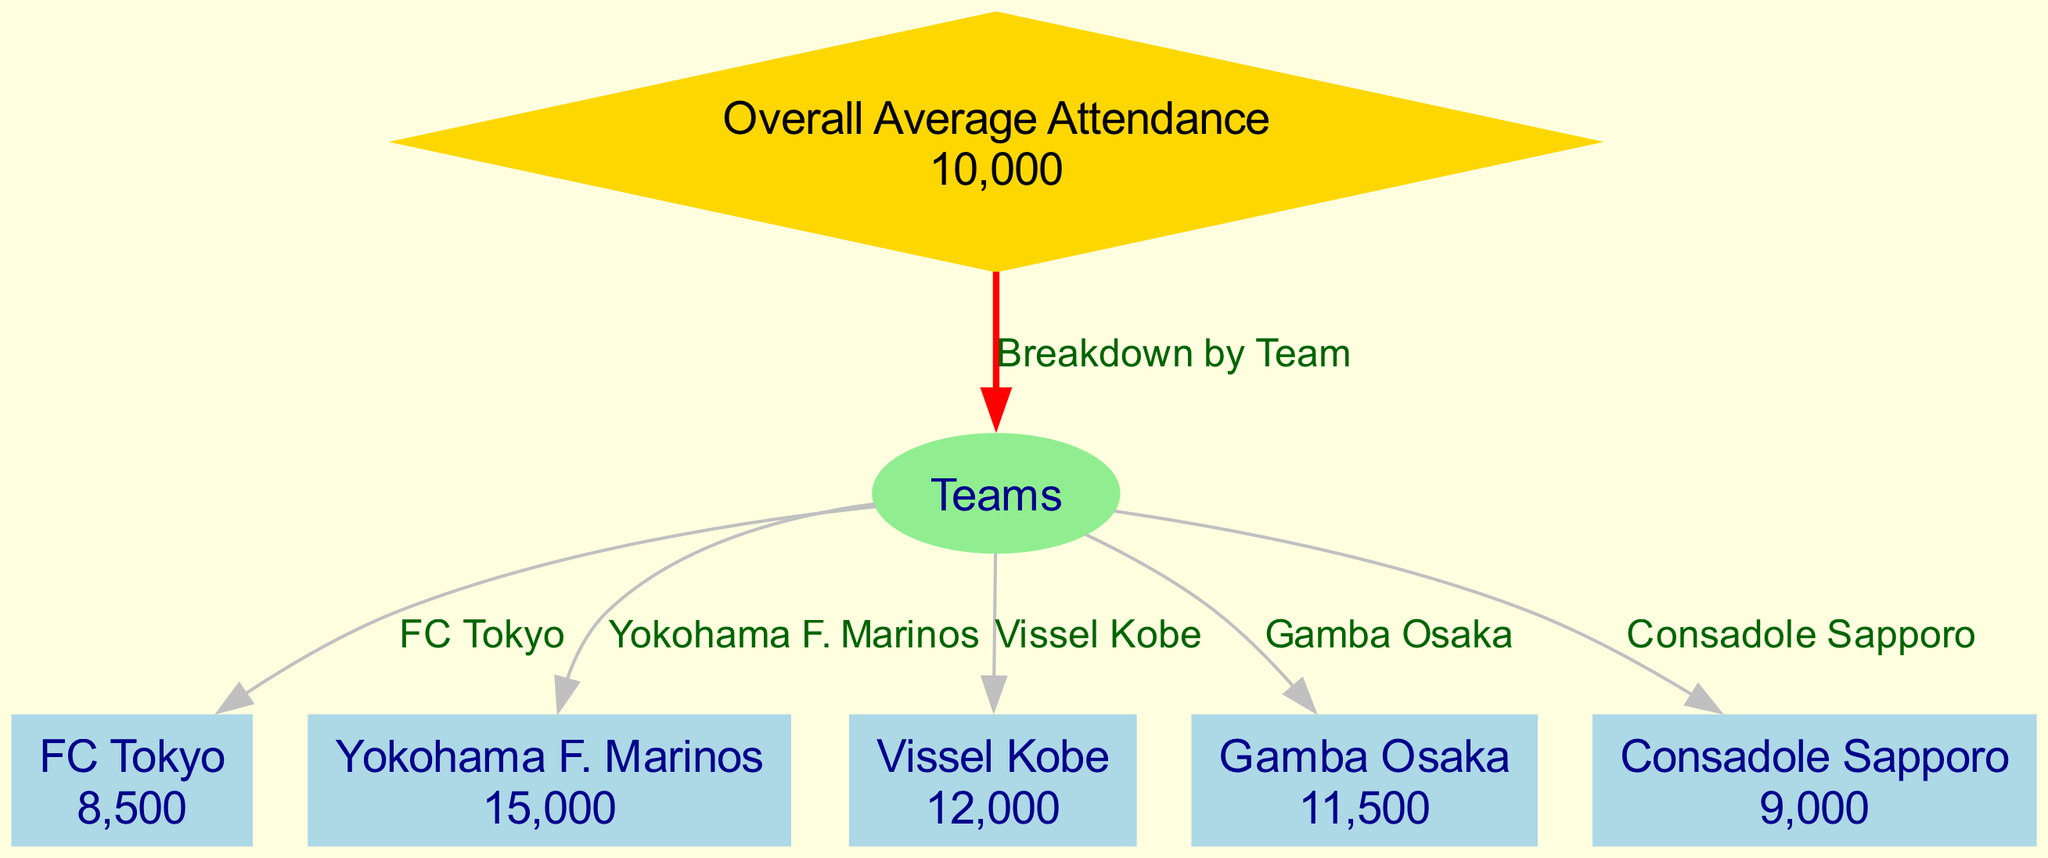What is the overall average attendance for the J1 League in the 2021 season? The overall average attendance node displays the value "10,000", which represents the average attendance across all teams in the J1 League for the specified season.
Answer: 10,000 Which team has the highest average attendance? Among the teams listed, Yokohama F. Marinos has the highest value at "15,000", indicating they attracted the most fans on average.
Answer: Yokohama F. Marinos How many teams are represented in the diagram? By counting the nodes connected to the teams node, we find there are five teams: FC Tokyo, Yokohama F. Marinos, Vissel Kobe, Gamba Osaka, and Consadole Sapporo.
Answer: 5 What average attendance does Vissel Kobe have? The diagram lists Vissel Kobe's average attendance as "12,000", which is presented in the corresponding node for that team.
Answer: 12,000 Is the attendance for FC Tokyo above or below the overall average? FC Tokyo's attendance is "8,500", which is below the overall average attendance of "10,000", as indicated in the overall average attendance node.
Answer: Below What is the relationship between overall average attendance and teams? The diagram shows that there is a "Breakdown by Team" relationship, illustrated by an edge connecting the overall average attendance node to the teams node.
Answer: Breakdown by Team Which team has an average attendance greater than the overall average? By evaluating attendance figures, Yokohama F. Marinos (15,000) and Vissel Kobe (12,000) have attendances that are greater than the overall average of 10,000.
Answer: Yokohama F. Marinos, Vissel Kobe What is the attendance value for Gamba Osaka? The corresponding node for Gamba Osaka presents its average attendance as "11,500", indicating the number of fans that typically attended matches.
Answer: 11,500 Which teams have average attendance figures below the overall average? The diagram shows FC Tokyo (8,500) and Consadole Sapporo (9,000), both of which fall below the overall average of 10,000.
Answer: FC Tokyo, Consadole Sapporo 